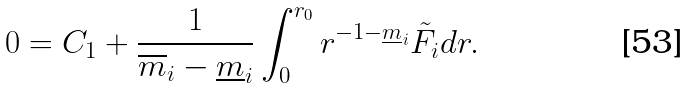Convert formula to latex. <formula><loc_0><loc_0><loc_500><loc_500>0 = C _ { 1 } + \frac { 1 } { \overline { m } _ { i } - \underline { m } _ { i } } \int _ { 0 } ^ { r _ { 0 } } r ^ { - 1 - \underline { m } _ { i } } \tilde { F } _ { i } d r .</formula> 